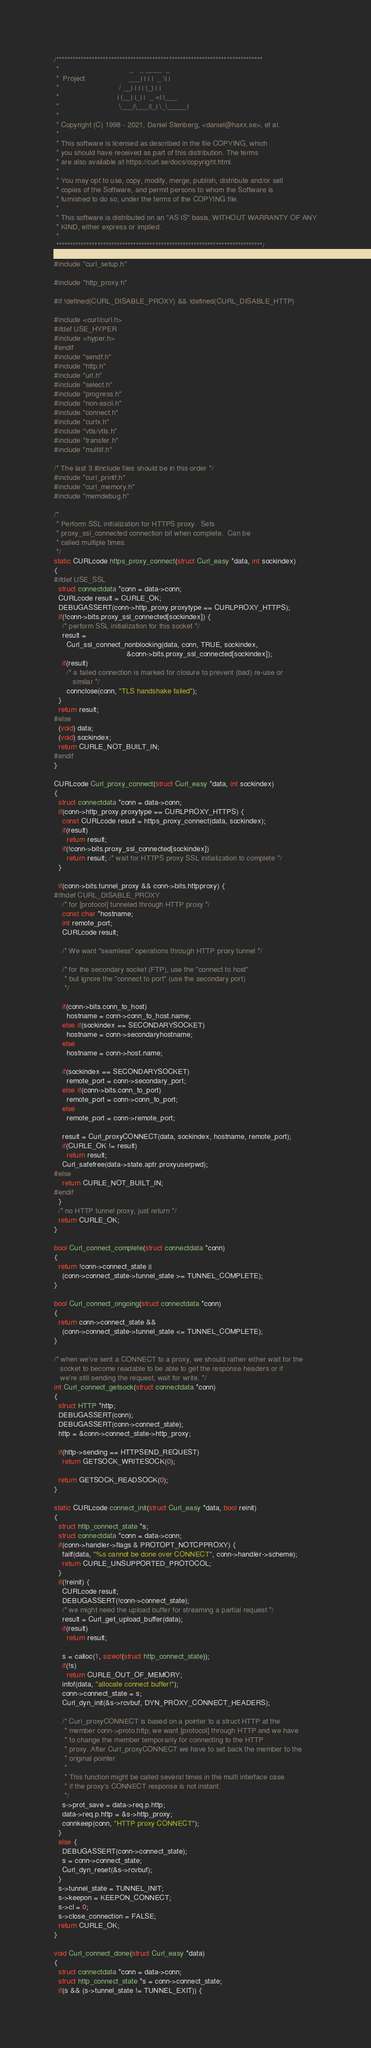Convert code to text. <code><loc_0><loc_0><loc_500><loc_500><_C_>/***************************************************************************
 *                                  _   _ ____  _
 *  Project                     ___| | | |  _ \| |
 *                             / __| | | | |_) | |
 *                            | (__| |_| |  _ <| |___
 *                             \___|\___/|_| \_\_____|
 *
 * Copyright (C) 1998 - 2021, Daniel Stenberg, <daniel@haxx.se>, et al.
 *
 * This software is licensed as described in the file COPYING, which
 * you should have received as part of this distribution. The terms
 * are also available at https://curl.se/docs/copyright.html.
 *
 * You may opt to use, copy, modify, merge, publish, distribute and/or sell
 * copies of the Software, and permit persons to whom the Software is
 * furnished to do so, under the terms of the COPYING file.
 *
 * This software is distributed on an "AS IS" basis, WITHOUT WARRANTY OF ANY
 * KIND, either express or implied.
 *
 ***************************************************************************/

#include "curl_setup.h"

#include "http_proxy.h"

#if !defined(CURL_DISABLE_PROXY) && !defined(CURL_DISABLE_HTTP)

#include <curl/curl.h>
#ifdef USE_HYPER
#include <hyper.h>
#endif
#include "sendf.h"
#include "http.h"
#include "url.h"
#include "select.h"
#include "progress.h"
#include "non-ascii.h"
#include "connect.h"
#include "curlx.h"
#include "vtls/vtls.h"
#include "transfer.h"
#include "multiif.h"

/* The last 3 #include files should be in this order */
#include "curl_printf.h"
#include "curl_memory.h"
#include "memdebug.h"

/*
 * Perform SSL initialization for HTTPS proxy.  Sets
 * proxy_ssl_connected connection bit when complete.  Can be
 * called multiple times.
 */
static CURLcode https_proxy_connect(struct Curl_easy *data, int sockindex)
{
#ifdef USE_SSL
  struct connectdata *conn = data->conn;
  CURLcode result = CURLE_OK;
  DEBUGASSERT(conn->http_proxy.proxytype == CURLPROXY_HTTPS);
  if(!conn->bits.proxy_ssl_connected[sockindex]) {
    /* perform SSL initialization for this socket */
    result =
      Curl_ssl_connect_nonblocking(data, conn, TRUE, sockindex,
                                   &conn->bits.proxy_ssl_connected[sockindex]);
    if(result)
      /* a failed connection is marked for closure to prevent (bad) re-use or
         similar */
      connclose(conn, "TLS handshake failed");
  }
  return result;
#else
  (void) data;
  (void) sockindex;
  return CURLE_NOT_BUILT_IN;
#endif
}

CURLcode Curl_proxy_connect(struct Curl_easy *data, int sockindex)
{
  struct connectdata *conn = data->conn;
  if(conn->http_proxy.proxytype == CURLPROXY_HTTPS) {
    const CURLcode result = https_proxy_connect(data, sockindex);
    if(result)
      return result;
    if(!conn->bits.proxy_ssl_connected[sockindex])
      return result; /* wait for HTTPS proxy SSL initialization to complete */
  }

  if(conn->bits.tunnel_proxy && conn->bits.httpproxy) {
#ifndef CURL_DISABLE_PROXY
    /* for [protocol] tunneled through HTTP proxy */
    const char *hostname;
    int remote_port;
    CURLcode result;

    /* We want "seamless" operations through HTTP proxy tunnel */

    /* for the secondary socket (FTP), use the "connect to host"
     * but ignore the "connect to port" (use the secondary port)
     */

    if(conn->bits.conn_to_host)
      hostname = conn->conn_to_host.name;
    else if(sockindex == SECONDARYSOCKET)
      hostname = conn->secondaryhostname;
    else
      hostname = conn->host.name;

    if(sockindex == SECONDARYSOCKET)
      remote_port = conn->secondary_port;
    else if(conn->bits.conn_to_port)
      remote_port = conn->conn_to_port;
    else
      remote_port = conn->remote_port;

    result = Curl_proxyCONNECT(data, sockindex, hostname, remote_port);
    if(CURLE_OK != result)
      return result;
    Curl_safefree(data->state.aptr.proxyuserpwd);
#else
    return CURLE_NOT_BUILT_IN;
#endif
  }
  /* no HTTP tunnel proxy, just return */
  return CURLE_OK;
}

bool Curl_connect_complete(struct connectdata *conn)
{
  return !conn->connect_state ||
    (conn->connect_state->tunnel_state >= TUNNEL_COMPLETE);
}

bool Curl_connect_ongoing(struct connectdata *conn)
{
  return conn->connect_state &&
    (conn->connect_state->tunnel_state <= TUNNEL_COMPLETE);
}

/* when we've sent a CONNECT to a proxy, we should rather either wait for the
   socket to become readable to be able to get the response headers or if
   we're still sending the request, wait for write. */
int Curl_connect_getsock(struct connectdata *conn)
{
  struct HTTP *http;
  DEBUGASSERT(conn);
  DEBUGASSERT(conn->connect_state);
  http = &conn->connect_state->http_proxy;

  if(http->sending == HTTPSEND_REQUEST)
    return GETSOCK_WRITESOCK(0);

  return GETSOCK_READSOCK(0);
}

static CURLcode connect_init(struct Curl_easy *data, bool reinit)
{
  struct http_connect_state *s;
  struct connectdata *conn = data->conn;
  if(conn->handler->flags & PROTOPT_NOTCPPROXY) {
    failf(data, "%s cannot be done over CONNECT", conn->handler->scheme);
    return CURLE_UNSUPPORTED_PROTOCOL;
  }
  if(!reinit) {
    CURLcode result;
    DEBUGASSERT(!conn->connect_state);
    /* we might need the upload buffer for streaming a partial request */
    result = Curl_get_upload_buffer(data);
    if(result)
      return result;

    s = calloc(1, sizeof(struct http_connect_state));
    if(!s)
      return CURLE_OUT_OF_MEMORY;
    infof(data, "allocate connect buffer!");
    conn->connect_state = s;
    Curl_dyn_init(&s->rcvbuf, DYN_PROXY_CONNECT_HEADERS);

    /* Curl_proxyCONNECT is based on a pointer to a struct HTTP at the
     * member conn->proto.http; we want [protocol] through HTTP and we have
     * to change the member temporarily for connecting to the HTTP
     * proxy. After Curl_proxyCONNECT we have to set back the member to the
     * original pointer
     *
     * This function might be called several times in the multi interface case
     * if the proxy's CONNECT response is not instant.
     */
    s->prot_save = data->req.p.http;
    data->req.p.http = &s->http_proxy;
    connkeep(conn, "HTTP proxy CONNECT");
  }
  else {
    DEBUGASSERT(conn->connect_state);
    s = conn->connect_state;
    Curl_dyn_reset(&s->rcvbuf);
  }
  s->tunnel_state = TUNNEL_INIT;
  s->keepon = KEEPON_CONNECT;
  s->cl = 0;
  s->close_connection = FALSE;
  return CURLE_OK;
}

void Curl_connect_done(struct Curl_easy *data)
{
  struct connectdata *conn = data->conn;
  struct http_connect_state *s = conn->connect_state;
  if(s && (s->tunnel_state != TUNNEL_EXIT)) {</code> 